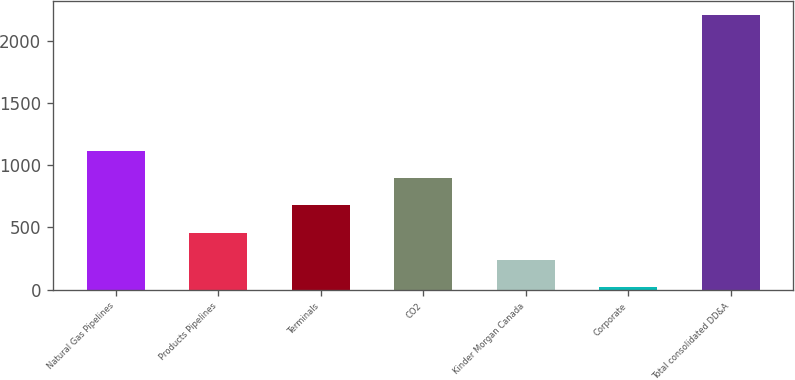<chart> <loc_0><loc_0><loc_500><loc_500><bar_chart><fcel>Natural Gas Pipelines<fcel>Products Pipelines<fcel>Terminals<fcel>CO2<fcel>Kinder Morgan Canada<fcel>Corporate<fcel>Total consolidated DD&A<nl><fcel>1115.5<fcel>459.4<fcel>678.1<fcel>896.8<fcel>240.7<fcel>22<fcel>2209<nl></chart> 